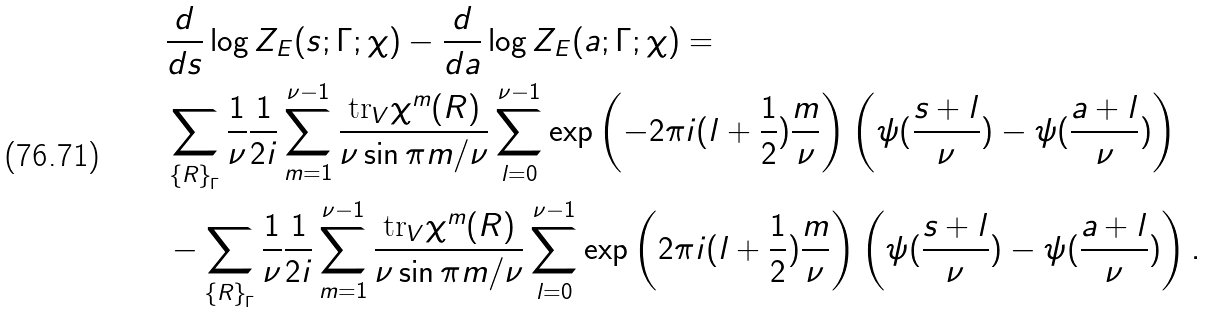Convert formula to latex. <formula><loc_0><loc_0><loc_500><loc_500>& \frac { d } { d s } \log Z _ { E } ( s ; \Gamma ; \chi ) - \frac { d } { d a } \log Z _ { E } ( a ; \Gamma ; \chi ) = \\ & \sum _ { \left \{ R \right \} _ { \Gamma } } \frac { 1 } { \nu } \frac { 1 } { 2 i } \sum _ { m = 1 } ^ { \nu - 1 } \frac { \text {tr} _ { V } \chi ^ { m } ( R ) } { \nu \sin \pi m / \nu } \sum _ { l = 0 } ^ { \nu - 1 } \exp \left ( - 2 \pi i ( l + \frac { 1 } { 2 } ) \frac { m } { \nu } \right ) \left ( \psi ( \frac { s + l } { \nu } ) - \psi ( \frac { a + l } { \nu } ) \right ) \\ & - \sum _ { \left \{ R \right \} _ { \Gamma } } \frac { 1 } { \nu } \frac { 1 } { 2 i } \sum _ { m = 1 } ^ { \nu - 1 } \frac { \text {tr} _ { V } \chi ^ { m } ( R ) } { \nu \sin \pi m / \nu } \sum _ { l = 0 } ^ { \nu - 1 } \exp \left ( 2 \pi i ( l + \frac { 1 } { 2 } ) \frac { m } { \nu } \right ) \left ( \psi ( \frac { s + l } { \nu } ) - \psi ( \frac { a + l } { \nu } ) \right ) .</formula> 